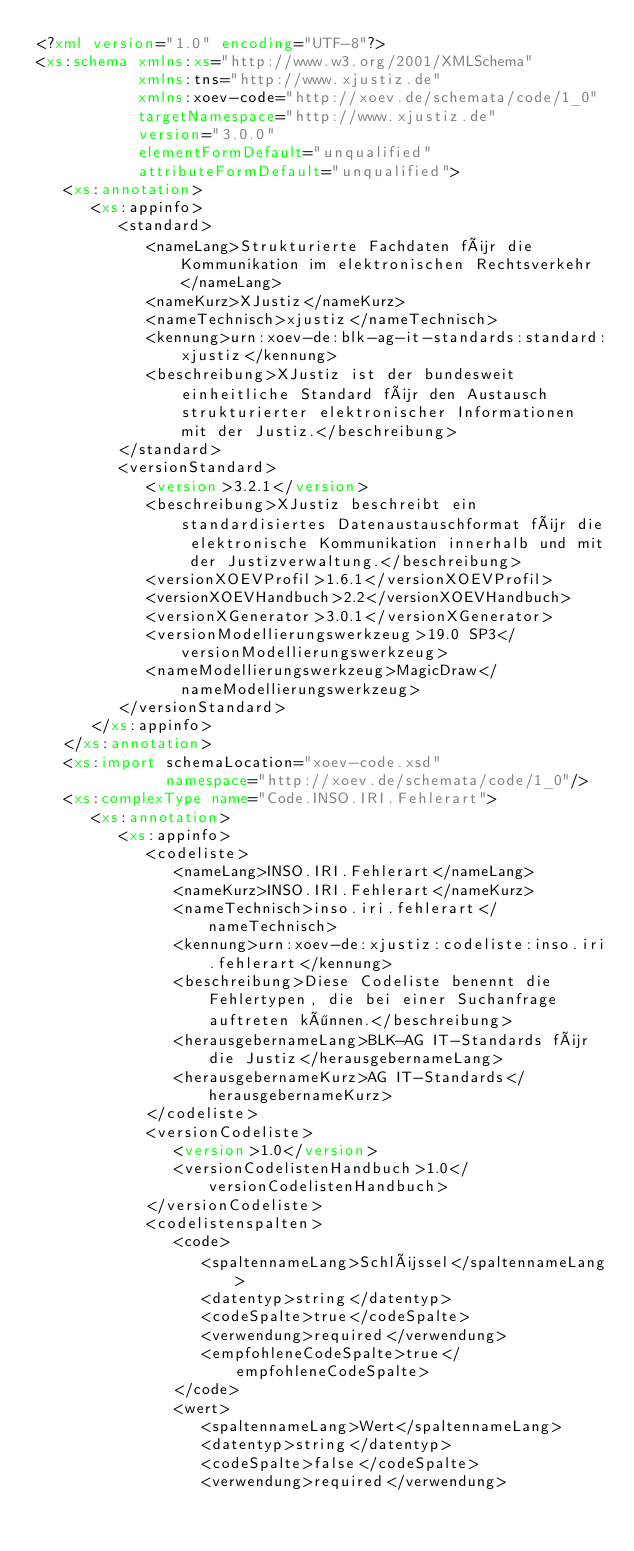Convert code to text. <code><loc_0><loc_0><loc_500><loc_500><_XML_><?xml version="1.0" encoding="UTF-8"?>
<xs:schema xmlns:xs="http://www.w3.org/2001/XMLSchema"
           xmlns:tns="http://www.xjustiz.de"
           xmlns:xoev-code="http://xoev.de/schemata/code/1_0"
           targetNamespace="http://www.xjustiz.de"
           version="3.0.0"
           elementFormDefault="unqualified"
           attributeFormDefault="unqualified">
   <xs:annotation>
      <xs:appinfo>
         <standard>
            <nameLang>Strukturierte Fachdaten für die Kommunikation im elektronischen Rechtsverkehr</nameLang>
            <nameKurz>XJustiz</nameKurz>
            <nameTechnisch>xjustiz</nameTechnisch>
            <kennung>urn:xoev-de:blk-ag-it-standards:standard:xjustiz</kennung>
            <beschreibung>XJustiz ist der bundesweit einheitliche Standard für den Austausch strukturierter elektronischer Informationen mit der Justiz.</beschreibung>
         </standard>
         <versionStandard>
            <version>3.2.1</version>
            <beschreibung>XJustiz beschreibt ein standardisiertes Datenaustauschformat für die elektronische Kommunikation innerhalb und mit der Justizverwaltung.</beschreibung>
            <versionXOEVProfil>1.6.1</versionXOEVProfil>
            <versionXOEVHandbuch>2.2</versionXOEVHandbuch>
            <versionXGenerator>3.0.1</versionXGenerator>
            <versionModellierungswerkzeug>19.0 SP3</versionModellierungswerkzeug>
            <nameModellierungswerkzeug>MagicDraw</nameModellierungswerkzeug>
         </versionStandard>
      </xs:appinfo>
   </xs:annotation>
   <xs:import schemaLocation="xoev-code.xsd"
              namespace="http://xoev.de/schemata/code/1_0"/>
   <xs:complexType name="Code.INSO.IRI.Fehlerart">
      <xs:annotation>
         <xs:appinfo>
            <codeliste>
               <nameLang>INSO.IRI.Fehlerart</nameLang>
               <nameKurz>INSO.IRI.Fehlerart</nameKurz>
               <nameTechnisch>inso.iri.fehlerart</nameTechnisch>
               <kennung>urn:xoev-de:xjustiz:codeliste:inso.iri.fehlerart</kennung>
               <beschreibung>Diese Codeliste benennt die Fehlertypen, die bei einer Suchanfrage auftreten können.</beschreibung>
               <herausgebernameLang>BLK-AG IT-Standards für die Justiz</herausgebernameLang>
               <herausgebernameKurz>AG IT-Standards</herausgebernameKurz>
            </codeliste>
            <versionCodeliste>
               <version>1.0</version>
               <versionCodelistenHandbuch>1.0</versionCodelistenHandbuch>
            </versionCodeliste>
            <codelistenspalten>
               <code>
                  <spaltennameLang>Schlüssel</spaltennameLang>
                  <datentyp>string</datentyp>
                  <codeSpalte>true</codeSpalte>
                  <verwendung>required</verwendung>
                  <empfohleneCodeSpalte>true</empfohleneCodeSpalte>
               </code>
               <wert>
                  <spaltennameLang>Wert</spaltennameLang>
                  <datentyp>string</datentyp>
                  <codeSpalte>false</codeSpalte>
                  <verwendung>required</verwendung></code> 